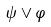<formula> <loc_0><loc_0><loc_500><loc_500>\psi \vee \varphi</formula> 